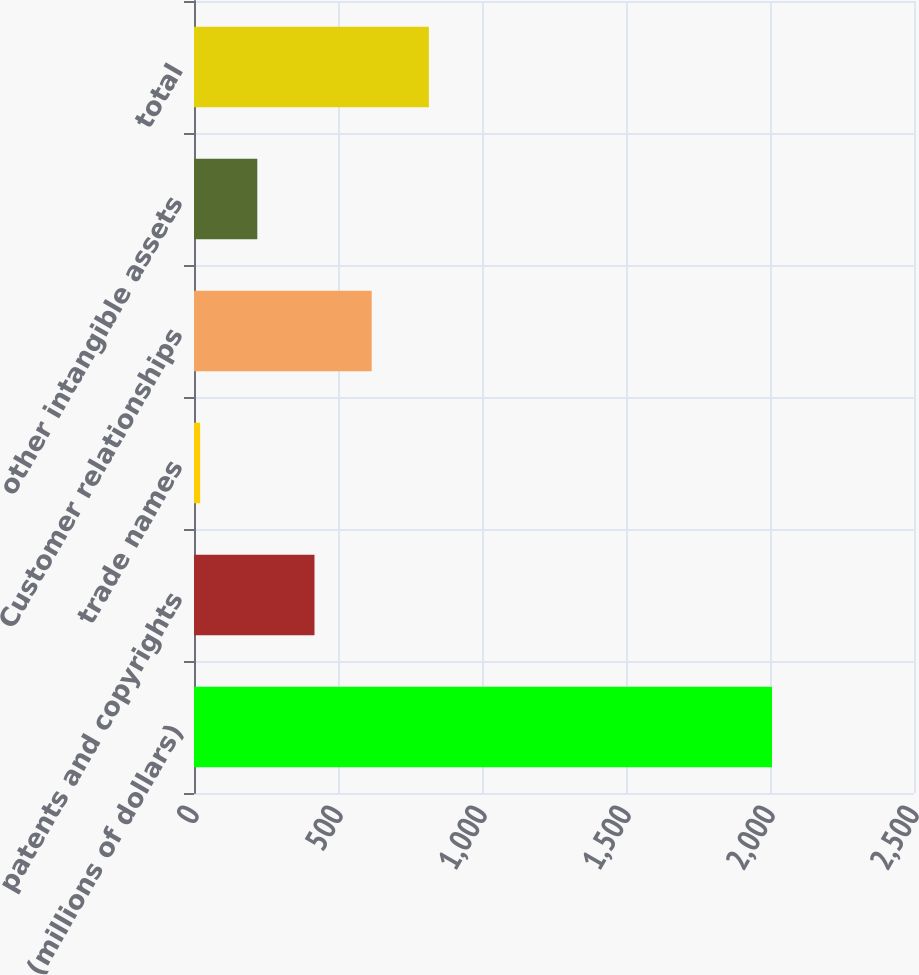<chart> <loc_0><loc_0><loc_500><loc_500><bar_chart><fcel>(millions of dollars)<fcel>patents and copyrights<fcel>trade names<fcel>Customer relationships<fcel>other intangible assets<fcel>total<nl><fcel>2007<fcel>418.36<fcel>21.2<fcel>616.94<fcel>219.78<fcel>815.52<nl></chart> 